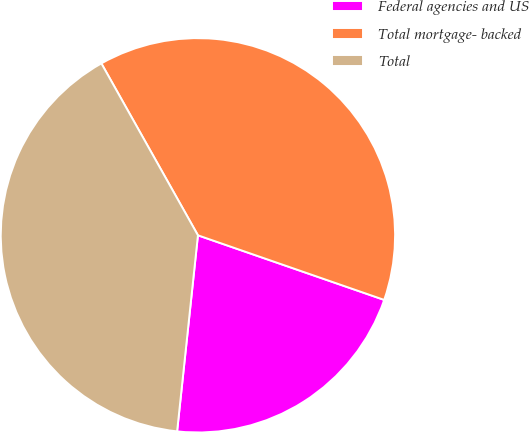<chart> <loc_0><loc_0><loc_500><loc_500><pie_chart><fcel>Federal agencies and US<fcel>Total mortgage- backed<fcel>Total<nl><fcel>21.37%<fcel>38.46%<fcel>40.17%<nl></chart> 